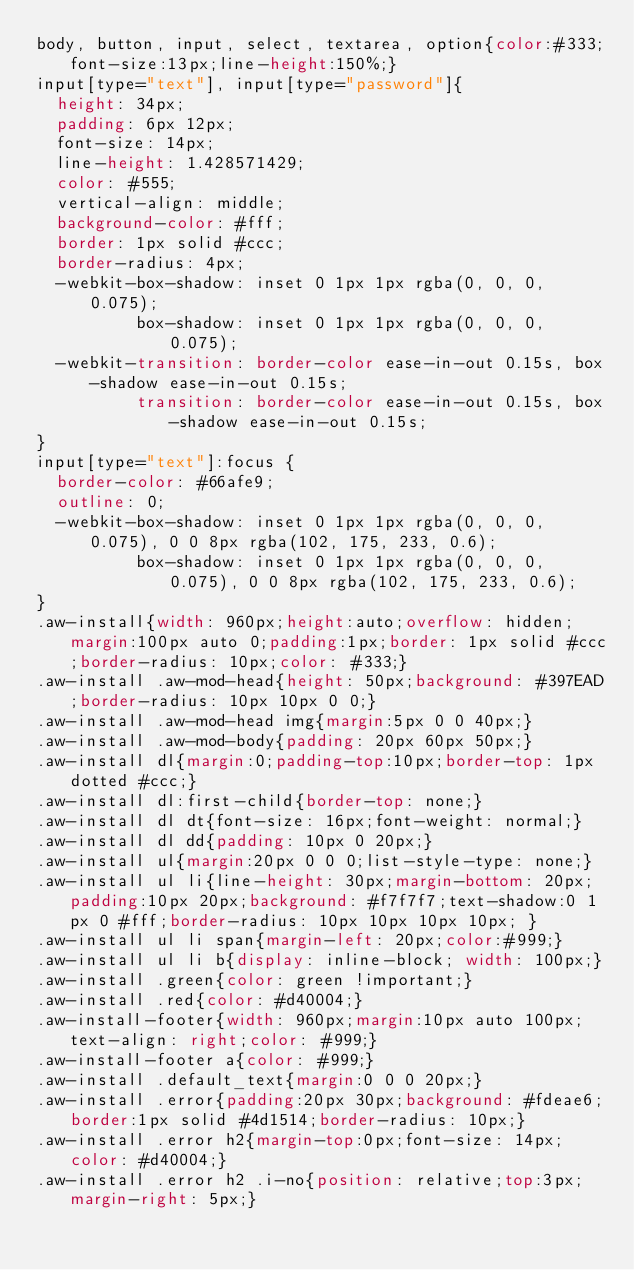<code> <loc_0><loc_0><loc_500><loc_500><_CSS_>body, button, input, select, textarea, option{color:#333;font-size:13px;line-height:150%;}
input[type="text"], input[type="password"]{
  height: 34px;
  padding: 6px 12px;
  font-size: 14px;
  line-height: 1.428571429;
  color: #555;
  vertical-align: middle;
  background-color: #fff;
  border: 1px solid #ccc;
  border-radius: 4px;
  -webkit-box-shadow: inset 0 1px 1px rgba(0, 0, 0, 0.075);
          box-shadow: inset 0 1px 1px rgba(0, 0, 0, 0.075);
  -webkit-transition: border-color ease-in-out 0.15s, box-shadow ease-in-out 0.15s;
          transition: border-color ease-in-out 0.15s, box-shadow ease-in-out 0.15s;
}
input[type="text"]:focus {
  border-color: #66afe9;
  outline: 0;
  -webkit-box-shadow: inset 0 1px 1px rgba(0, 0, 0, 0.075), 0 0 8px rgba(102, 175, 233, 0.6);
          box-shadow: inset 0 1px 1px rgba(0, 0, 0, 0.075), 0 0 8px rgba(102, 175, 233, 0.6);
}
.aw-install{width: 960px;height:auto;overflow: hidden;margin:100px auto 0;padding:1px;border: 1px solid #ccc;border-radius: 10px;color: #333;}
.aw-install .aw-mod-head{height: 50px;background: #397EAD;border-radius: 10px 10px 0 0;}
.aw-install .aw-mod-head img{margin:5px 0 0 40px;}
.aw-install .aw-mod-body{padding: 20px 60px 50px;}
.aw-install dl{margin:0;padding-top:10px;border-top: 1px dotted #ccc;}
.aw-install dl:first-child{border-top: none;}
.aw-install dl dt{font-size: 16px;font-weight: normal;}
.aw-install dl dd{padding: 10px 0 20px;}
.aw-install ul{margin:20px 0 0 0;list-style-type: none;}
.aw-install ul li{line-height: 30px;margin-bottom: 20px;padding:10px 20px;background: #f7f7f7;text-shadow:0 1px 0 #fff;border-radius: 10px 10px 10px 10px; }
.aw-install ul li span{margin-left: 20px;color:#999;}
.aw-install ul li b{display: inline-block; width: 100px;}
.aw-install .green{color: green !important;}
.aw-install .red{color: #d40004;}
.aw-install-footer{width: 960px;margin:10px auto 100px;text-align: right;color: #999;}
.aw-install-footer a{color: #999;}
.aw-install .default_text{margin:0 0 0 20px;}
.aw-install .error{padding:20px 30px;background: #fdeae6;border:1px solid #4d1514;border-radius: 10px;}
.aw-install .error h2{margin-top:0px;font-size: 14px;color: #d40004;}
.aw-install .error h2 .i-no{position: relative;top:3px;margin-right: 5px;}

</code> 